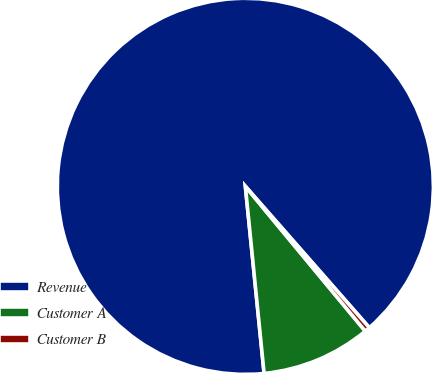Convert chart. <chart><loc_0><loc_0><loc_500><loc_500><pie_chart><fcel>Revenue<fcel>Customer A<fcel>Customer B<nl><fcel>90.14%<fcel>9.42%<fcel>0.45%<nl></chart> 